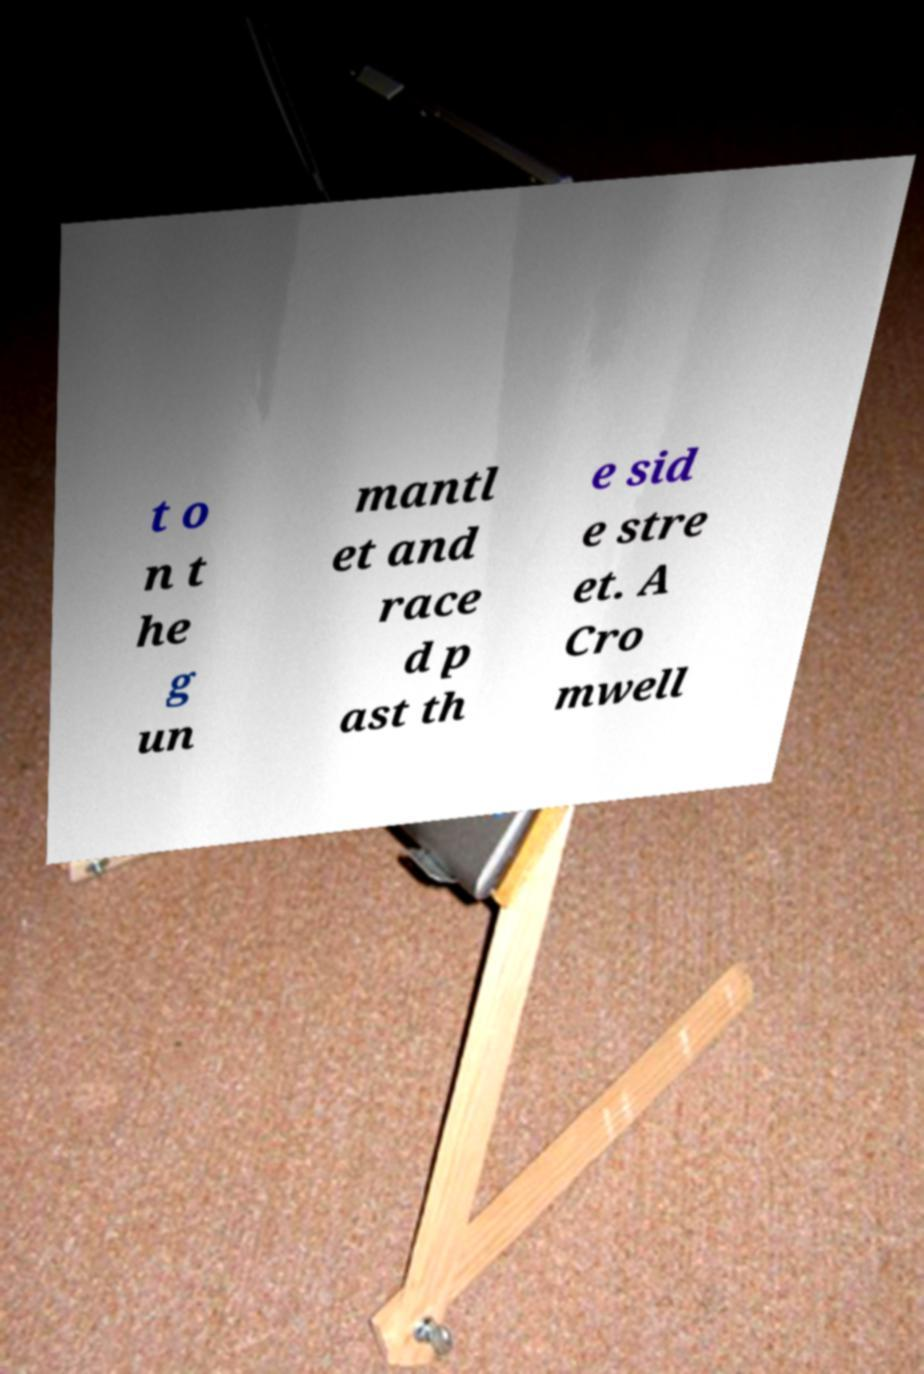What messages or text are displayed in this image? I need them in a readable, typed format. t o n t he g un mantl et and race d p ast th e sid e stre et. A Cro mwell 